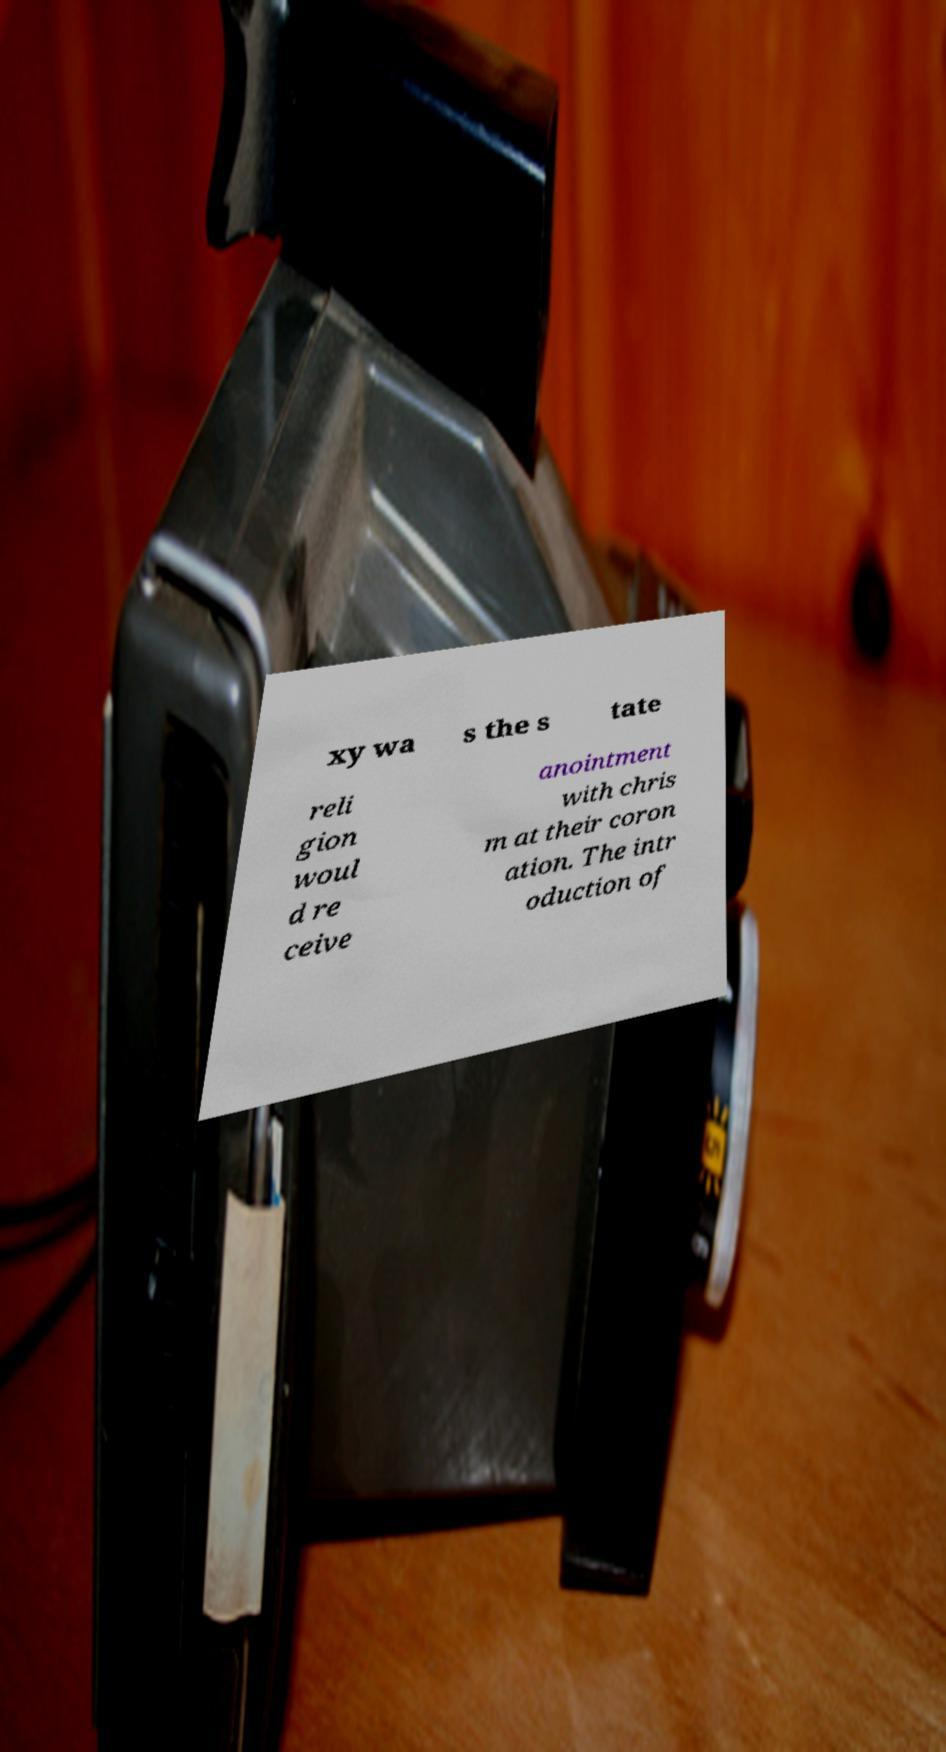Please read and relay the text visible in this image. What does it say? xy wa s the s tate reli gion woul d re ceive anointment with chris m at their coron ation. The intr oduction of 